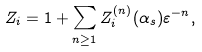Convert formula to latex. <formula><loc_0><loc_0><loc_500><loc_500>Z _ { i } = 1 + \sum _ { n \geq 1 } Z ^ { ( n ) } _ { i } ( \alpha _ { s } ) \varepsilon ^ { - n } ,</formula> 